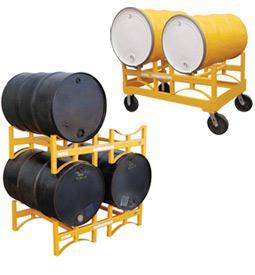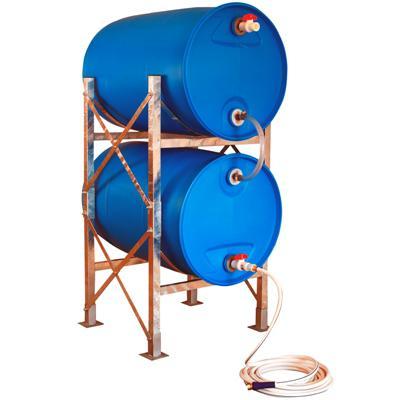The first image is the image on the left, the second image is the image on the right. For the images shown, is this caption "One image shows exactly two blue barrels." true? Answer yes or no. Yes. The first image is the image on the left, the second image is the image on the right. Considering the images on both sides, is "Each image contains at least one blue barrel, and at least 6 blue barrels in total are shown." valid? Answer yes or no. No. 